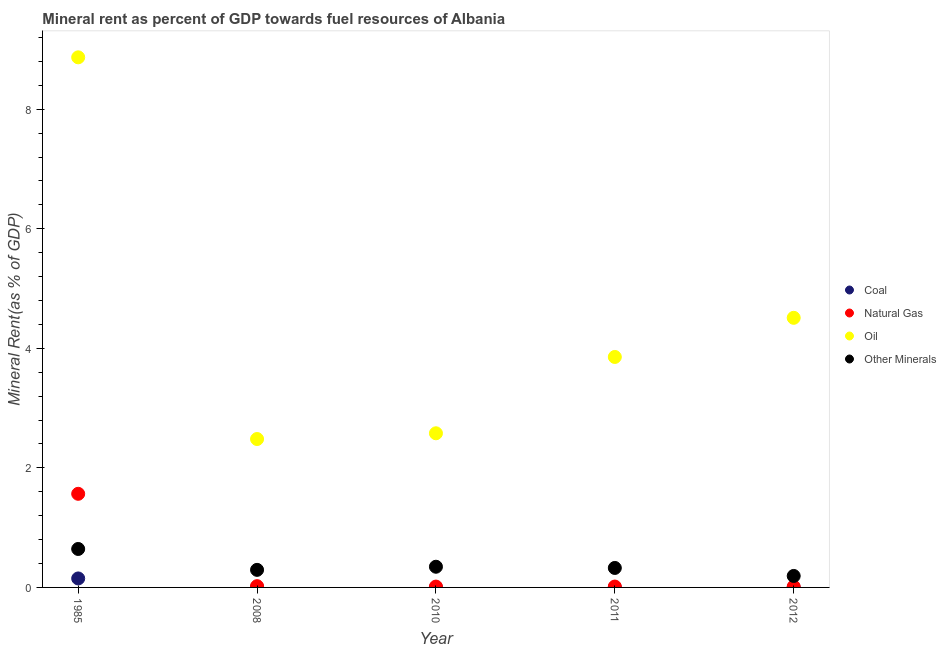What is the  rent of other minerals in 2012?
Keep it short and to the point. 0.19. Across all years, what is the maximum natural gas rent?
Your answer should be compact. 1.57. Across all years, what is the minimum oil rent?
Give a very brief answer. 2.48. What is the total oil rent in the graph?
Your answer should be compact. 22.3. What is the difference between the oil rent in 2010 and that in 2012?
Give a very brief answer. -1.93. What is the difference between the natural gas rent in 1985 and the coal rent in 2010?
Your response must be concise. 1.57. What is the average natural gas rent per year?
Your response must be concise. 0.33. In the year 2008, what is the difference between the oil rent and natural gas rent?
Offer a terse response. 2.46. In how many years, is the coal rent greater than 1.6 %?
Provide a short and direct response. 0. What is the ratio of the natural gas rent in 2008 to that in 2010?
Make the answer very short. 1.52. Is the natural gas rent in 2010 less than that in 2012?
Keep it short and to the point. No. Is the difference between the oil rent in 1985 and 2011 greater than the difference between the  rent of other minerals in 1985 and 2011?
Ensure brevity in your answer.  Yes. What is the difference between the highest and the second highest  rent of other minerals?
Your response must be concise. 0.3. What is the difference between the highest and the lowest natural gas rent?
Give a very brief answer. 1.55. In how many years, is the oil rent greater than the average oil rent taken over all years?
Keep it short and to the point. 2. Is it the case that in every year, the sum of the  rent of other minerals and coal rent is greater than the sum of natural gas rent and oil rent?
Provide a succinct answer. No. Is it the case that in every year, the sum of the coal rent and natural gas rent is greater than the oil rent?
Provide a succinct answer. No. Does the coal rent monotonically increase over the years?
Ensure brevity in your answer.  No. Is the oil rent strictly greater than the coal rent over the years?
Give a very brief answer. Yes. Are the values on the major ticks of Y-axis written in scientific E-notation?
Offer a very short reply. No. Does the graph contain grids?
Your response must be concise. No. How many legend labels are there?
Your answer should be compact. 4. How are the legend labels stacked?
Offer a very short reply. Vertical. What is the title of the graph?
Provide a short and direct response. Mineral rent as percent of GDP towards fuel resources of Albania. Does "France" appear as one of the legend labels in the graph?
Your answer should be very brief. No. What is the label or title of the X-axis?
Your answer should be very brief. Year. What is the label or title of the Y-axis?
Offer a very short reply. Mineral Rent(as % of GDP). What is the Mineral Rent(as % of GDP) of Coal in 1985?
Provide a succinct answer. 0.15. What is the Mineral Rent(as % of GDP) of Natural Gas in 1985?
Offer a terse response. 1.57. What is the Mineral Rent(as % of GDP) of Oil in 1985?
Your response must be concise. 8.87. What is the Mineral Rent(as % of GDP) in Other Minerals in 1985?
Your response must be concise. 0.64. What is the Mineral Rent(as % of GDP) of Coal in 2008?
Provide a short and direct response. 0. What is the Mineral Rent(as % of GDP) in Natural Gas in 2008?
Your answer should be compact. 0.02. What is the Mineral Rent(as % of GDP) of Oil in 2008?
Offer a very short reply. 2.48. What is the Mineral Rent(as % of GDP) in Other Minerals in 2008?
Offer a terse response. 0.29. What is the Mineral Rent(as % of GDP) of Coal in 2010?
Give a very brief answer. 0. What is the Mineral Rent(as % of GDP) in Natural Gas in 2010?
Provide a short and direct response. 0.01. What is the Mineral Rent(as % of GDP) of Oil in 2010?
Make the answer very short. 2.58. What is the Mineral Rent(as % of GDP) in Other Minerals in 2010?
Provide a short and direct response. 0.35. What is the Mineral Rent(as % of GDP) of Coal in 2011?
Your answer should be very brief. 0. What is the Mineral Rent(as % of GDP) in Natural Gas in 2011?
Offer a very short reply. 0.01. What is the Mineral Rent(as % of GDP) in Oil in 2011?
Offer a very short reply. 3.86. What is the Mineral Rent(as % of GDP) of Other Minerals in 2011?
Your response must be concise. 0.33. What is the Mineral Rent(as % of GDP) of Coal in 2012?
Provide a short and direct response. 2.82780495009493e-5. What is the Mineral Rent(as % of GDP) in Natural Gas in 2012?
Provide a succinct answer. 0.01. What is the Mineral Rent(as % of GDP) in Oil in 2012?
Your response must be concise. 4.51. What is the Mineral Rent(as % of GDP) in Other Minerals in 2012?
Give a very brief answer. 0.19. Across all years, what is the maximum Mineral Rent(as % of GDP) in Coal?
Your response must be concise. 0.15. Across all years, what is the maximum Mineral Rent(as % of GDP) of Natural Gas?
Your answer should be compact. 1.57. Across all years, what is the maximum Mineral Rent(as % of GDP) in Oil?
Your answer should be very brief. 8.87. Across all years, what is the maximum Mineral Rent(as % of GDP) of Other Minerals?
Give a very brief answer. 0.64. Across all years, what is the minimum Mineral Rent(as % of GDP) in Coal?
Your answer should be very brief. 2.82780495009493e-5. Across all years, what is the minimum Mineral Rent(as % of GDP) of Natural Gas?
Provide a succinct answer. 0.01. Across all years, what is the minimum Mineral Rent(as % of GDP) in Oil?
Make the answer very short. 2.48. Across all years, what is the minimum Mineral Rent(as % of GDP) in Other Minerals?
Your answer should be very brief. 0.19. What is the total Mineral Rent(as % of GDP) in Coal in the graph?
Your answer should be very brief. 0.15. What is the total Mineral Rent(as % of GDP) in Natural Gas in the graph?
Offer a very short reply. 1.63. What is the total Mineral Rent(as % of GDP) of Oil in the graph?
Keep it short and to the point. 22.3. What is the total Mineral Rent(as % of GDP) of Other Minerals in the graph?
Ensure brevity in your answer.  1.8. What is the difference between the Mineral Rent(as % of GDP) of Coal in 1985 and that in 2008?
Provide a succinct answer. 0.15. What is the difference between the Mineral Rent(as % of GDP) of Natural Gas in 1985 and that in 2008?
Your answer should be very brief. 1.54. What is the difference between the Mineral Rent(as % of GDP) in Oil in 1985 and that in 2008?
Ensure brevity in your answer.  6.39. What is the difference between the Mineral Rent(as % of GDP) of Other Minerals in 1985 and that in 2008?
Your answer should be very brief. 0.35. What is the difference between the Mineral Rent(as % of GDP) in Coal in 1985 and that in 2010?
Your answer should be very brief. 0.15. What is the difference between the Mineral Rent(as % of GDP) of Natural Gas in 1985 and that in 2010?
Your answer should be very brief. 1.55. What is the difference between the Mineral Rent(as % of GDP) of Oil in 1985 and that in 2010?
Provide a succinct answer. 6.29. What is the difference between the Mineral Rent(as % of GDP) of Other Minerals in 1985 and that in 2010?
Offer a very short reply. 0.3. What is the difference between the Mineral Rent(as % of GDP) of Coal in 1985 and that in 2011?
Provide a succinct answer. 0.15. What is the difference between the Mineral Rent(as % of GDP) in Natural Gas in 1985 and that in 2011?
Give a very brief answer. 1.55. What is the difference between the Mineral Rent(as % of GDP) of Oil in 1985 and that in 2011?
Your answer should be compact. 5.01. What is the difference between the Mineral Rent(as % of GDP) in Other Minerals in 1985 and that in 2011?
Give a very brief answer. 0.32. What is the difference between the Mineral Rent(as % of GDP) in Coal in 1985 and that in 2012?
Your answer should be compact. 0.15. What is the difference between the Mineral Rent(as % of GDP) of Natural Gas in 1985 and that in 2012?
Provide a succinct answer. 1.55. What is the difference between the Mineral Rent(as % of GDP) in Oil in 1985 and that in 2012?
Your response must be concise. 4.36. What is the difference between the Mineral Rent(as % of GDP) of Other Minerals in 1985 and that in 2012?
Make the answer very short. 0.45. What is the difference between the Mineral Rent(as % of GDP) of Coal in 2008 and that in 2010?
Offer a terse response. 0. What is the difference between the Mineral Rent(as % of GDP) in Natural Gas in 2008 and that in 2010?
Your answer should be compact. 0.01. What is the difference between the Mineral Rent(as % of GDP) of Oil in 2008 and that in 2010?
Keep it short and to the point. -0.1. What is the difference between the Mineral Rent(as % of GDP) of Other Minerals in 2008 and that in 2010?
Ensure brevity in your answer.  -0.05. What is the difference between the Mineral Rent(as % of GDP) of Coal in 2008 and that in 2011?
Provide a succinct answer. 0. What is the difference between the Mineral Rent(as % of GDP) of Natural Gas in 2008 and that in 2011?
Provide a succinct answer. 0.01. What is the difference between the Mineral Rent(as % of GDP) of Oil in 2008 and that in 2011?
Offer a terse response. -1.37. What is the difference between the Mineral Rent(as % of GDP) of Other Minerals in 2008 and that in 2011?
Give a very brief answer. -0.03. What is the difference between the Mineral Rent(as % of GDP) of Coal in 2008 and that in 2012?
Offer a terse response. 0. What is the difference between the Mineral Rent(as % of GDP) in Natural Gas in 2008 and that in 2012?
Make the answer very short. 0.01. What is the difference between the Mineral Rent(as % of GDP) of Oil in 2008 and that in 2012?
Provide a short and direct response. -2.03. What is the difference between the Mineral Rent(as % of GDP) of Other Minerals in 2008 and that in 2012?
Offer a terse response. 0.1. What is the difference between the Mineral Rent(as % of GDP) in Coal in 2010 and that in 2011?
Provide a short and direct response. -0. What is the difference between the Mineral Rent(as % of GDP) in Natural Gas in 2010 and that in 2011?
Keep it short and to the point. -0. What is the difference between the Mineral Rent(as % of GDP) of Oil in 2010 and that in 2011?
Offer a very short reply. -1.28. What is the difference between the Mineral Rent(as % of GDP) in Other Minerals in 2010 and that in 2011?
Offer a terse response. 0.02. What is the difference between the Mineral Rent(as % of GDP) of Coal in 2010 and that in 2012?
Make the answer very short. 0. What is the difference between the Mineral Rent(as % of GDP) in Natural Gas in 2010 and that in 2012?
Ensure brevity in your answer.  0. What is the difference between the Mineral Rent(as % of GDP) of Oil in 2010 and that in 2012?
Give a very brief answer. -1.93. What is the difference between the Mineral Rent(as % of GDP) of Other Minerals in 2010 and that in 2012?
Provide a short and direct response. 0.15. What is the difference between the Mineral Rent(as % of GDP) in Natural Gas in 2011 and that in 2012?
Keep it short and to the point. 0. What is the difference between the Mineral Rent(as % of GDP) of Oil in 2011 and that in 2012?
Provide a succinct answer. -0.66. What is the difference between the Mineral Rent(as % of GDP) in Other Minerals in 2011 and that in 2012?
Make the answer very short. 0.13. What is the difference between the Mineral Rent(as % of GDP) of Coal in 1985 and the Mineral Rent(as % of GDP) of Natural Gas in 2008?
Offer a terse response. 0.13. What is the difference between the Mineral Rent(as % of GDP) in Coal in 1985 and the Mineral Rent(as % of GDP) in Oil in 2008?
Your answer should be very brief. -2.33. What is the difference between the Mineral Rent(as % of GDP) of Coal in 1985 and the Mineral Rent(as % of GDP) of Other Minerals in 2008?
Provide a short and direct response. -0.14. What is the difference between the Mineral Rent(as % of GDP) of Natural Gas in 1985 and the Mineral Rent(as % of GDP) of Oil in 2008?
Your answer should be very brief. -0.92. What is the difference between the Mineral Rent(as % of GDP) of Natural Gas in 1985 and the Mineral Rent(as % of GDP) of Other Minerals in 2008?
Make the answer very short. 1.27. What is the difference between the Mineral Rent(as % of GDP) in Oil in 1985 and the Mineral Rent(as % of GDP) in Other Minerals in 2008?
Your answer should be compact. 8.58. What is the difference between the Mineral Rent(as % of GDP) in Coal in 1985 and the Mineral Rent(as % of GDP) in Natural Gas in 2010?
Your answer should be compact. 0.14. What is the difference between the Mineral Rent(as % of GDP) of Coal in 1985 and the Mineral Rent(as % of GDP) of Oil in 2010?
Make the answer very short. -2.43. What is the difference between the Mineral Rent(as % of GDP) in Coal in 1985 and the Mineral Rent(as % of GDP) in Other Minerals in 2010?
Your response must be concise. -0.2. What is the difference between the Mineral Rent(as % of GDP) of Natural Gas in 1985 and the Mineral Rent(as % of GDP) of Oil in 2010?
Your answer should be compact. -1.01. What is the difference between the Mineral Rent(as % of GDP) of Natural Gas in 1985 and the Mineral Rent(as % of GDP) of Other Minerals in 2010?
Ensure brevity in your answer.  1.22. What is the difference between the Mineral Rent(as % of GDP) in Oil in 1985 and the Mineral Rent(as % of GDP) in Other Minerals in 2010?
Provide a short and direct response. 8.52. What is the difference between the Mineral Rent(as % of GDP) of Coal in 1985 and the Mineral Rent(as % of GDP) of Natural Gas in 2011?
Give a very brief answer. 0.14. What is the difference between the Mineral Rent(as % of GDP) of Coal in 1985 and the Mineral Rent(as % of GDP) of Oil in 2011?
Your answer should be compact. -3.71. What is the difference between the Mineral Rent(as % of GDP) of Coal in 1985 and the Mineral Rent(as % of GDP) of Other Minerals in 2011?
Give a very brief answer. -0.18. What is the difference between the Mineral Rent(as % of GDP) in Natural Gas in 1985 and the Mineral Rent(as % of GDP) in Oil in 2011?
Provide a succinct answer. -2.29. What is the difference between the Mineral Rent(as % of GDP) in Natural Gas in 1985 and the Mineral Rent(as % of GDP) in Other Minerals in 2011?
Your answer should be very brief. 1.24. What is the difference between the Mineral Rent(as % of GDP) of Oil in 1985 and the Mineral Rent(as % of GDP) of Other Minerals in 2011?
Provide a short and direct response. 8.54. What is the difference between the Mineral Rent(as % of GDP) in Coal in 1985 and the Mineral Rent(as % of GDP) in Natural Gas in 2012?
Make the answer very short. 0.14. What is the difference between the Mineral Rent(as % of GDP) in Coal in 1985 and the Mineral Rent(as % of GDP) in Oil in 2012?
Your answer should be very brief. -4.36. What is the difference between the Mineral Rent(as % of GDP) in Coal in 1985 and the Mineral Rent(as % of GDP) in Other Minerals in 2012?
Your response must be concise. -0.04. What is the difference between the Mineral Rent(as % of GDP) in Natural Gas in 1985 and the Mineral Rent(as % of GDP) in Oil in 2012?
Ensure brevity in your answer.  -2.94. What is the difference between the Mineral Rent(as % of GDP) of Natural Gas in 1985 and the Mineral Rent(as % of GDP) of Other Minerals in 2012?
Make the answer very short. 1.37. What is the difference between the Mineral Rent(as % of GDP) in Oil in 1985 and the Mineral Rent(as % of GDP) in Other Minerals in 2012?
Offer a terse response. 8.68. What is the difference between the Mineral Rent(as % of GDP) of Coal in 2008 and the Mineral Rent(as % of GDP) of Natural Gas in 2010?
Your answer should be very brief. -0.01. What is the difference between the Mineral Rent(as % of GDP) in Coal in 2008 and the Mineral Rent(as % of GDP) in Oil in 2010?
Provide a short and direct response. -2.58. What is the difference between the Mineral Rent(as % of GDP) of Coal in 2008 and the Mineral Rent(as % of GDP) of Other Minerals in 2010?
Your answer should be compact. -0.34. What is the difference between the Mineral Rent(as % of GDP) of Natural Gas in 2008 and the Mineral Rent(as % of GDP) of Oil in 2010?
Provide a short and direct response. -2.56. What is the difference between the Mineral Rent(as % of GDP) of Natural Gas in 2008 and the Mineral Rent(as % of GDP) of Other Minerals in 2010?
Your response must be concise. -0.32. What is the difference between the Mineral Rent(as % of GDP) of Oil in 2008 and the Mineral Rent(as % of GDP) of Other Minerals in 2010?
Make the answer very short. 2.14. What is the difference between the Mineral Rent(as % of GDP) in Coal in 2008 and the Mineral Rent(as % of GDP) in Natural Gas in 2011?
Ensure brevity in your answer.  -0.01. What is the difference between the Mineral Rent(as % of GDP) of Coal in 2008 and the Mineral Rent(as % of GDP) of Oil in 2011?
Make the answer very short. -3.85. What is the difference between the Mineral Rent(as % of GDP) of Coal in 2008 and the Mineral Rent(as % of GDP) of Other Minerals in 2011?
Ensure brevity in your answer.  -0.32. What is the difference between the Mineral Rent(as % of GDP) of Natural Gas in 2008 and the Mineral Rent(as % of GDP) of Oil in 2011?
Provide a short and direct response. -3.83. What is the difference between the Mineral Rent(as % of GDP) of Natural Gas in 2008 and the Mineral Rent(as % of GDP) of Other Minerals in 2011?
Your response must be concise. -0.3. What is the difference between the Mineral Rent(as % of GDP) in Oil in 2008 and the Mineral Rent(as % of GDP) in Other Minerals in 2011?
Give a very brief answer. 2.16. What is the difference between the Mineral Rent(as % of GDP) of Coal in 2008 and the Mineral Rent(as % of GDP) of Natural Gas in 2012?
Offer a very short reply. -0.01. What is the difference between the Mineral Rent(as % of GDP) in Coal in 2008 and the Mineral Rent(as % of GDP) in Oil in 2012?
Provide a succinct answer. -4.51. What is the difference between the Mineral Rent(as % of GDP) in Coal in 2008 and the Mineral Rent(as % of GDP) in Other Minerals in 2012?
Ensure brevity in your answer.  -0.19. What is the difference between the Mineral Rent(as % of GDP) of Natural Gas in 2008 and the Mineral Rent(as % of GDP) of Oil in 2012?
Your response must be concise. -4.49. What is the difference between the Mineral Rent(as % of GDP) of Natural Gas in 2008 and the Mineral Rent(as % of GDP) of Other Minerals in 2012?
Provide a short and direct response. -0.17. What is the difference between the Mineral Rent(as % of GDP) in Oil in 2008 and the Mineral Rent(as % of GDP) in Other Minerals in 2012?
Provide a succinct answer. 2.29. What is the difference between the Mineral Rent(as % of GDP) in Coal in 2010 and the Mineral Rent(as % of GDP) in Natural Gas in 2011?
Your answer should be very brief. -0.01. What is the difference between the Mineral Rent(as % of GDP) of Coal in 2010 and the Mineral Rent(as % of GDP) of Oil in 2011?
Ensure brevity in your answer.  -3.86. What is the difference between the Mineral Rent(as % of GDP) in Coal in 2010 and the Mineral Rent(as % of GDP) in Other Minerals in 2011?
Make the answer very short. -0.33. What is the difference between the Mineral Rent(as % of GDP) of Natural Gas in 2010 and the Mineral Rent(as % of GDP) of Oil in 2011?
Offer a very short reply. -3.84. What is the difference between the Mineral Rent(as % of GDP) of Natural Gas in 2010 and the Mineral Rent(as % of GDP) of Other Minerals in 2011?
Offer a terse response. -0.31. What is the difference between the Mineral Rent(as % of GDP) in Oil in 2010 and the Mineral Rent(as % of GDP) in Other Minerals in 2011?
Offer a terse response. 2.25. What is the difference between the Mineral Rent(as % of GDP) in Coal in 2010 and the Mineral Rent(as % of GDP) in Natural Gas in 2012?
Ensure brevity in your answer.  -0.01. What is the difference between the Mineral Rent(as % of GDP) in Coal in 2010 and the Mineral Rent(as % of GDP) in Oil in 2012?
Your answer should be compact. -4.51. What is the difference between the Mineral Rent(as % of GDP) of Coal in 2010 and the Mineral Rent(as % of GDP) of Other Minerals in 2012?
Offer a terse response. -0.19. What is the difference between the Mineral Rent(as % of GDP) of Natural Gas in 2010 and the Mineral Rent(as % of GDP) of Oil in 2012?
Offer a terse response. -4.5. What is the difference between the Mineral Rent(as % of GDP) of Natural Gas in 2010 and the Mineral Rent(as % of GDP) of Other Minerals in 2012?
Your answer should be very brief. -0.18. What is the difference between the Mineral Rent(as % of GDP) in Oil in 2010 and the Mineral Rent(as % of GDP) in Other Minerals in 2012?
Your answer should be compact. 2.39. What is the difference between the Mineral Rent(as % of GDP) in Coal in 2011 and the Mineral Rent(as % of GDP) in Natural Gas in 2012?
Give a very brief answer. -0.01. What is the difference between the Mineral Rent(as % of GDP) of Coal in 2011 and the Mineral Rent(as % of GDP) of Oil in 2012?
Ensure brevity in your answer.  -4.51. What is the difference between the Mineral Rent(as % of GDP) in Coal in 2011 and the Mineral Rent(as % of GDP) in Other Minerals in 2012?
Your answer should be very brief. -0.19. What is the difference between the Mineral Rent(as % of GDP) of Natural Gas in 2011 and the Mineral Rent(as % of GDP) of Oil in 2012?
Offer a terse response. -4.5. What is the difference between the Mineral Rent(as % of GDP) in Natural Gas in 2011 and the Mineral Rent(as % of GDP) in Other Minerals in 2012?
Ensure brevity in your answer.  -0.18. What is the difference between the Mineral Rent(as % of GDP) of Oil in 2011 and the Mineral Rent(as % of GDP) of Other Minerals in 2012?
Ensure brevity in your answer.  3.66. What is the average Mineral Rent(as % of GDP) in Coal per year?
Your answer should be very brief. 0.03. What is the average Mineral Rent(as % of GDP) of Natural Gas per year?
Give a very brief answer. 0.33. What is the average Mineral Rent(as % of GDP) in Oil per year?
Ensure brevity in your answer.  4.46. What is the average Mineral Rent(as % of GDP) in Other Minerals per year?
Give a very brief answer. 0.36. In the year 1985, what is the difference between the Mineral Rent(as % of GDP) in Coal and Mineral Rent(as % of GDP) in Natural Gas?
Make the answer very short. -1.42. In the year 1985, what is the difference between the Mineral Rent(as % of GDP) of Coal and Mineral Rent(as % of GDP) of Oil?
Your answer should be very brief. -8.72. In the year 1985, what is the difference between the Mineral Rent(as % of GDP) of Coal and Mineral Rent(as % of GDP) of Other Minerals?
Your answer should be compact. -0.49. In the year 1985, what is the difference between the Mineral Rent(as % of GDP) in Natural Gas and Mineral Rent(as % of GDP) in Oil?
Provide a short and direct response. -7.3. In the year 1985, what is the difference between the Mineral Rent(as % of GDP) in Natural Gas and Mineral Rent(as % of GDP) in Other Minerals?
Your response must be concise. 0.92. In the year 1985, what is the difference between the Mineral Rent(as % of GDP) in Oil and Mineral Rent(as % of GDP) in Other Minerals?
Provide a short and direct response. 8.23. In the year 2008, what is the difference between the Mineral Rent(as % of GDP) of Coal and Mineral Rent(as % of GDP) of Natural Gas?
Provide a short and direct response. -0.02. In the year 2008, what is the difference between the Mineral Rent(as % of GDP) of Coal and Mineral Rent(as % of GDP) of Oil?
Give a very brief answer. -2.48. In the year 2008, what is the difference between the Mineral Rent(as % of GDP) in Coal and Mineral Rent(as % of GDP) in Other Minerals?
Provide a short and direct response. -0.29. In the year 2008, what is the difference between the Mineral Rent(as % of GDP) of Natural Gas and Mineral Rent(as % of GDP) of Oil?
Provide a succinct answer. -2.46. In the year 2008, what is the difference between the Mineral Rent(as % of GDP) of Natural Gas and Mineral Rent(as % of GDP) of Other Minerals?
Ensure brevity in your answer.  -0.27. In the year 2008, what is the difference between the Mineral Rent(as % of GDP) of Oil and Mineral Rent(as % of GDP) of Other Minerals?
Make the answer very short. 2.19. In the year 2010, what is the difference between the Mineral Rent(as % of GDP) in Coal and Mineral Rent(as % of GDP) in Natural Gas?
Your response must be concise. -0.01. In the year 2010, what is the difference between the Mineral Rent(as % of GDP) in Coal and Mineral Rent(as % of GDP) in Oil?
Keep it short and to the point. -2.58. In the year 2010, what is the difference between the Mineral Rent(as % of GDP) of Coal and Mineral Rent(as % of GDP) of Other Minerals?
Provide a short and direct response. -0.35. In the year 2010, what is the difference between the Mineral Rent(as % of GDP) of Natural Gas and Mineral Rent(as % of GDP) of Oil?
Offer a terse response. -2.56. In the year 2010, what is the difference between the Mineral Rent(as % of GDP) of Natural Gas and Mineral Rent(as % of GDP) of Other Minerals?
Offer a very short reply. -0.33. In the year 2010, what is the difference between the Mineral Rent(as % of GDP) of Oil and Mineral Rent(as % of GDP) of Other Minerals?
Make the answer very short. 2.23. In the year 2011, what is the difference between the Mineral Rent(as % of GDP) of Coal and Mineral Rent(as % of GDP) of Natural Gas?
Give a very brief answer. -0.01. In the year 2011, what is the difference between the Mineral Rent(as % of GDP) of Coal and Mineral Rent(as % of GDP) of Oil?
Offer a very short reply. -3.86. In the year 2011, what is the difference between the Mineral Rent(as % of GDP) in Coal and Mineral Rent(as % of GDP) in Other Minerals?
Ensure brevity in your answer.  -0.33. In the year 2011, what is the difference between the Mineral Rent(as % of GDP) of Natural Gas and Mineral Rent(as % of GDP) of Oil?
Your response must be concise. -3.84. In the year 2011, what is the difference between the Mineral Rent(as % of GDP) of Natural Gas and Mineral Rent(as % of GDP) of Other Minerals?
Provide a short and direct response. -0.31. In the year 2011, what is the difference between the Mineral Rent(as % of GDP) in Oil and Mineral Rent(as % of GDP) in Other Minerals?
Keep it short and to the point. 3.53. In the year 2012, what is the difference between the Mineral Rent(as % of GDP) in Coal and Mineral Rent(as % of GDP) in Natural Gas?
Your answer should be compact. -0.01. In the year 2012, what is the difference between the Mineral Rent(as % of GDP) of Coal and Mineral Rent(as % of GDP) of Oil?
Your answer should be compact. -4.51. In the year 2012, what is the difference between the Mineral Rent(as % of GDP) in Coal and Mineral Rent(as % of GDP) in Other Minerals?
Offer a terse response. -0.19. In the year 2012, what is the difference between the Mineral Rent(as % of GDP) in Natural Gas and Mineral Rent(as % of GDP) in Oil?
Your response must be concise. -4.5. In the year 2012, what is the difference between the Mineral Rent(as % of GDP) in Natural Gas and Mineral Rent(as % of GDP) in Other Minerals?
Ensure brevity in your answer.  -0.18. In the year 2012, what is the difference between the Mineral Rent(as % of GDP) in Oil and Mineral Rent(as % of GDP) in Other Minerals?
Provide a succinct answer. 4.32. What is the ratio of the Mineral Rent(as % of GDP) of Coal in 1985 to that in 2008?
Offer a terse response. 51.55. What is the ratio of the Mineral Rent(as % of GDP) of Natural Gas in 1985 to that in 2008?
Provide a short and direct response. 73.02. What is the ratio of the Mineral Rent(as % of GDP) in Oil in 1985 to that in 2008?
Offer a very short reply. 3.57. What is the ratio of the Mineral Rent(as % of GDP) in Other Minerals in 1985 to that in 2008?
Provide a short and direct response. 2.19. What is the ratio of the Mineral Rent(as % of GDP) of Coal in 1985 to that in 2010?
Ensure brevity in your answer.  1196.46. What is the ratio of the Mineral Rent(as % of GDP) of Natural Gas in 1985 to that in 2010?
Your answer should be compact. 110.78. What is the ratio of the Mineral Rent(as % of GDP) in Oil in 1985 to that in 2010?
Offer a very short reply. 3.44. What is the ratio of the Mineral Rent(as % of GDP) in Other Minerals in 1985 to that in 2010?
Your response must be concise. 1.86. What is the ratio of the Mineral Rent(as % of GDP) of Coal in 1985 to that in 2011?
Offer a terse response. 593.21. What is the ratio of the Mineral Rent(as % of GDP) of Natural Gas in 1985 to that in 2011?
Your answer should be compact. 106.22. What is the ratio of the Mineral Rent(as % of GDP) of Oil in 1985 to that in 2011?
Give a very brief answer. 2.3. What is the ratio of the Mineral Rent(as % of GDP) of Other Minerals in 1985 to that in 2011?
Make the answer very short. 1.97. What is the ratio of the Mineral Rent(as % of GDP) of Coal in 1985 to that in 2012?
Give a very brief answer. 5316.45. What is the ratio of the Mineral Rent(as % of GDP) of Natural Gas in 1985 to that in 2012?
Keep it short and to the point. 117.14. What is the ratio of the Mineral Rent(as % of GDP) in Oil in 1985 to that in 2012?
Your answer should be very brief. 1.97. What is the ratio of the Mineral Rent(as % of GDP) in Other Minerals in 1985 to that in 2012?
Make the answer very short. 3.35. What is the ratio of the Mineral Rent(as % of GDP) of Coal in 2008 to that in 2010?
Your answer should be very brief. 23.21. What is the ratio of the Mineral Rent(as % of GDP) of Natural Gas in 2008 to that in 2010?
Provide a short and direct response. 1.52. What is the ratio of the Mineral Rent(as % of GDP) in Oil in 2008 to that in 2010?
Your answer should be compact. 0.96. What is the ratio of the Mineral Rent(as % of GDP) in Other Minerals in 2008 to that in 2010?
Make the answer very short. 0.85. What is the ratio of the Mineral Rent(as % of GDP) of Coal in 2008 to that in 2011?
Keep it short and to the point. 11.51. What is the ratio of the Mineral Rent(as % of GDP) in Natural Gas in 2008 to that in 2011?
Your answer should be very brief. 1.45. What is the ratio of the Mineral Rent(as % of GDP) in Oil in 2008 to that in 2011?
Your response must be concise. 0.64. What is the ratio of the Mineral Rent(as % of GDP) of Other Minerals in 2008 to that in 2011?
Make the answer very short. 0.9. What is the ratio of the Mineral Rent(as % of GDP) of Coal in 2008 to that in 2012?
Keep it short and to the point. 103.12. What is the ratio of the Mineral Rent(as % of GDP) in Natural Gas in 2008 to that in 2012?
Your response must be concise. 1.6. What is the ratio of the Mineral Rent(as % of GDP) in Oil in 2008 to that in 2012?
Provide a short and direct response. 0.55. What is the ratio of the Mineral Rent(as % of GDP) in Other Minerals in 2008 to that in 2012?
Ensure brevity in your answer.  1.53. What is the ratio of the Mineral Rent(as % of GDP) in Coal in 2010 to that in 2011?
Offer a very short reply. 0.5. What is the ratio of the Mineral Rent(as % of GDP) of Natural Gas in 2010 to that in 2011?
Offer a very short reply. 0.96. What is the ratio of the Mineral Rent(as % of GDP) of Oil in 2010 to that in 2011?
Keep it short and to the point. 0.67. What is the ratio of the Mineral Rent(as % of GDP) of Other Minerals in 2010 to that in 2011?
Your response must be concise. 1.06. What is the ratio of the Mineral Rent(as % of GDP) in Coal in 2010 to that in 2012?
Ensure brevity in your answer.  4.44. What is the ratio of the Mineral Rent(as % of GDP) of Natural Gas in 2010 to that in 2012?
Give a very brief answer. 1.06. What is the ratio of the Mineral Rent(as % of GDP) in Oil in 2010 to that in 2012?
Make the answer very short. 0.57. What is the ratio of the Mineral Rent(as % of GDP) in Other Minerals in 2010 to that in 2012?
Offer a terse response. 1.8. What is the ratio of the Mineral Rent(as % of GDP) in Coal in 2011 to that in 2012?
Provide a short and direct response. 8.96. What is the ratio of the Mineral Rent(as % of GDP) of Natural Gas in 2011 to that in 2012?
Provide a succinct answer. 1.1. What is the ratio of the Mineral Rent(as % of GDP) of Oil in 2011 to that in 2012?
Ensure brevity in your answer.  0.85. What is the ratio of the Mineral Rent(as % of GDP) of Other Minerals in 2011 to that in 2012?
Make the answer very short. 1.7. What is the difference between the highest and the second highest Mineral Rent(as % of GDP) of Coal?
Offer a terse response. 0.15. What is the difference between the highest and the second highest Mineral Rent(as % of GDP) of Natural Gas?
Give a very brief answer. 1.54. What is the difference between the highest and the second highest Mineral Rent(as % of GDP) of Oil?
Offer a very short reply. 4.36. What is the difference between the highest and the second highest Mineral Rent(as % of GDP) of Other Minerals?
Give a very brief answer. 0.3. What is the difference between the highest and the lowest Mineral Rent(as % of GDP) in Coal?
Your answer should be very brief. 0.15. What is the difference between the highest and the lowest Mineral Rent(as % of GDP) of Natural Gas?
Keep it short and to the point. 1.55. What is the difference between the highest and the lowest Mineral Rent(as % of GDP) in Oil?
Provide a short and direct response. 6.39. What is the difference between the highest and the lowest Mineral Rent(as % of GDP) of Other Minerals?
Offer a very short reply. 0.45. 